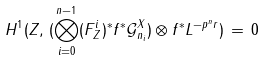<formula> <loc_0><loc_0><loc_500><loc_500>H ^ { 1 } ( Z , \, ( \bigotimes _ { i = 0 } ^ { n - 1 } ( F ^ { i } _ { Z } ) ^ { * } f ^ { * } { \mathcal { G } } ^ { X } _ { n _ { i } } ) \otimes f ^ { * } L ^ { - p ^ { n } r } ) \, = \, 0</formula> 